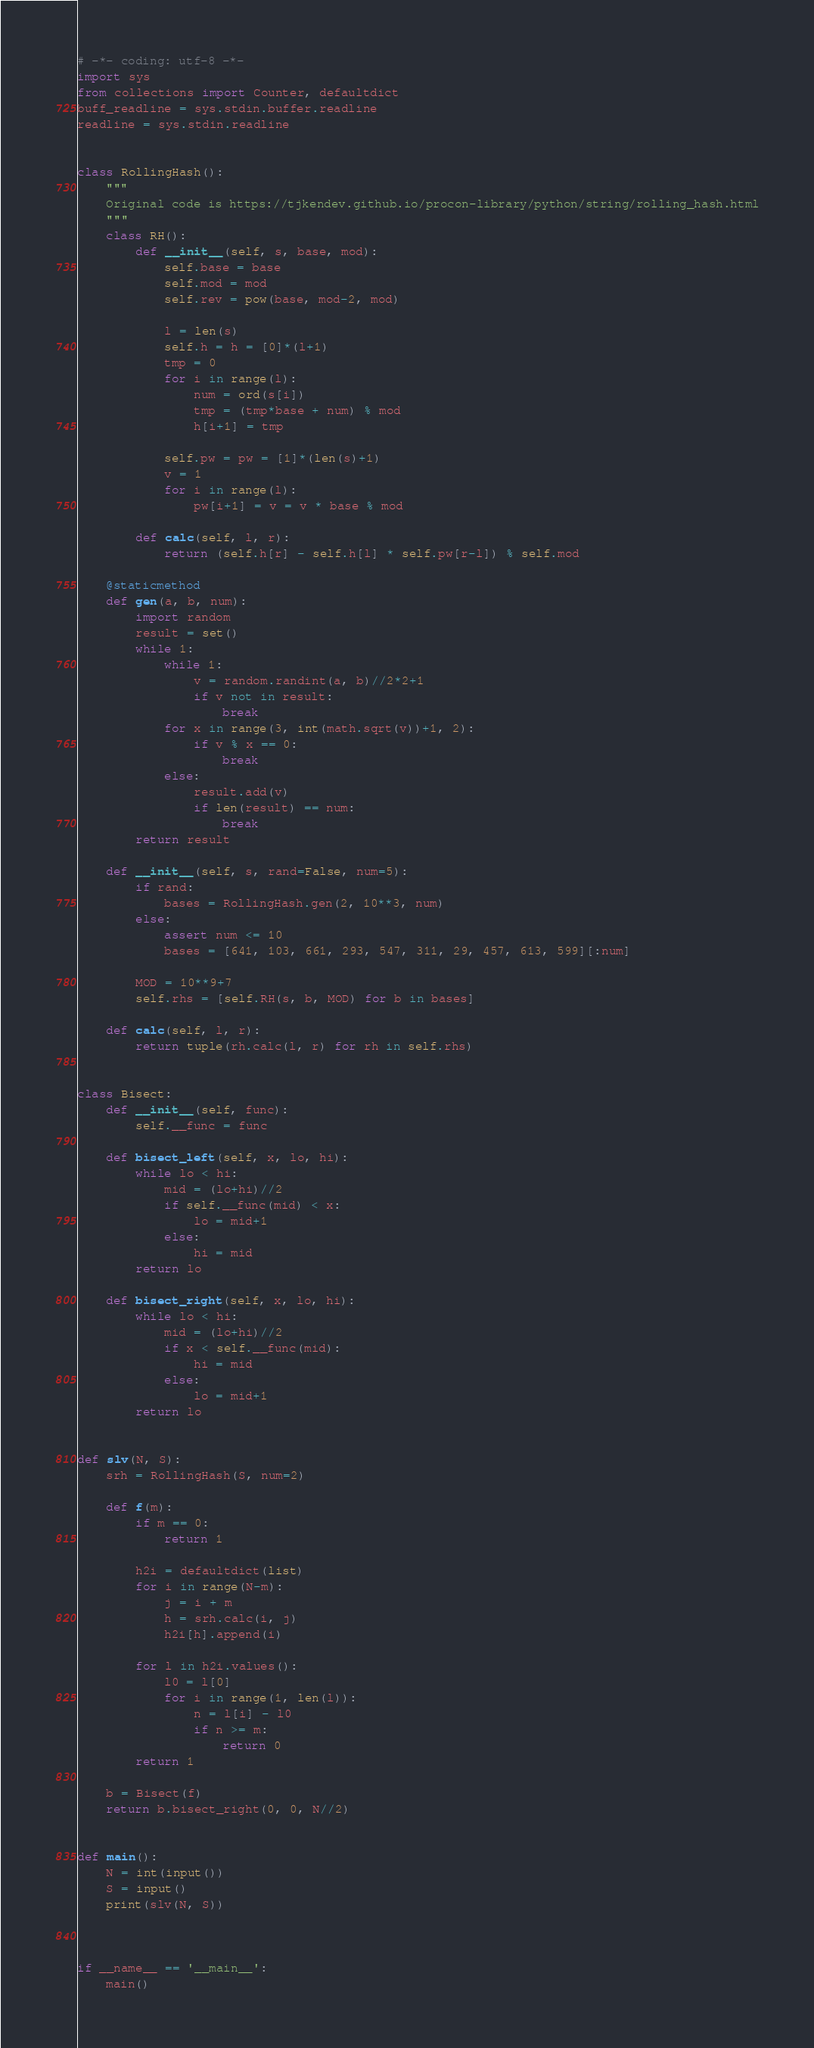<code> <loc_0><loc_0><loc_500><loc_500><_Python_># -*- coding: utf-8 -*-
import sys
from collections import Counter, defaultdict
buff_readline = sys.stdin.buffer.readline
readline = sys.stdin.readline


class RollingHash():
    """
    Original code is https://tjkendev.github.io/procon-library/python/string/rolling_hash.html
    """
    class RH():
        def __init__(self, s, base, mod):
            self.base = base
            self.mod = mod
            self.rev = pow(base, mod-2, mod)

            l = len(s)
            self.h = h = [0]*(l+1)
            tmp = 0
            for i in range(l):
                num = ord(s[i])
                tmp = (tmp*base + num) % mod
                h[i+1] = tmp

            self.pw = pw = [1]*(len(s)+1)
            v = 1
            for i in range(l):
                pw[i+1] = v = v * base % mod

        def calc(self, l, r):
            return (self.h[r] - self.h[l] * self.pw[r-l]) % self.mod

    @staticmethod
    def gen(a, b, num):
        import random
        result = set()
        while 1:
            while 1:
                v = random.randint(a, b)//2*2+1
                if v not in result:
                    break
            for x in range(3, int(math.sqrt(v))+1, 2):
                if v % x == 0:
                    break
            else:
                result.add(v)
                if len(result) == num:
                    break
        return result

    def __init__(self, s, rand=False, num=5):
        if rand:
            bases = RollingHash.gen(2, 10**3, num)
        else:
            assert num <= 10
            bases = [641, 103, 661, 293, 547, 311, 29, 457, 613, 599][:num]

        MOD = 10**9+7
        self.rhs = [self.RH(s, b, MOD) for b in bases]

    def calc(self, l, r):
        return tuple(rh.calc(l, r) for rh in self.rhs)


class Bisect:
    def __init__(self, func):
        self.__func = func

    def bisect_left(self, x, lo, hi):
        while lo < hi:
            mid = (lo+hi)//2
            if self.__func(mid) < x:
                lo = mid+1
            else:
                hi = mid
        return lo

    def bisect_right(self, x, lo, hi):
        while lo < hi:
            mid = (lo+hi)//2
            if x < self.__func(mid):
                hi = mid
            else:
                lo = mid+1
        return lo


def slv(N, S):
    srh = RollingHash(S, num=2)

    def f(m):
        if m == 0:
            return 1

        h2i = defaultdict(list)
        for i in range(N-m):
            j = i + m
            h = srh.calc(i, j)
            h2i[h].append(i)

        for l in h2i.values():
            l0 = l[0]
            for i in range(1, len(l)):
                n = l[i] - l0
                if n >= m:
                    return 0
        return 1

    b = Bisect(f)
    return b.bisect_right(0, 0, N//2)


def main():
    N = int(input())
    S = input()
    print(slv(N, S))



if __name__ == '__main__':
    main()
</code> 